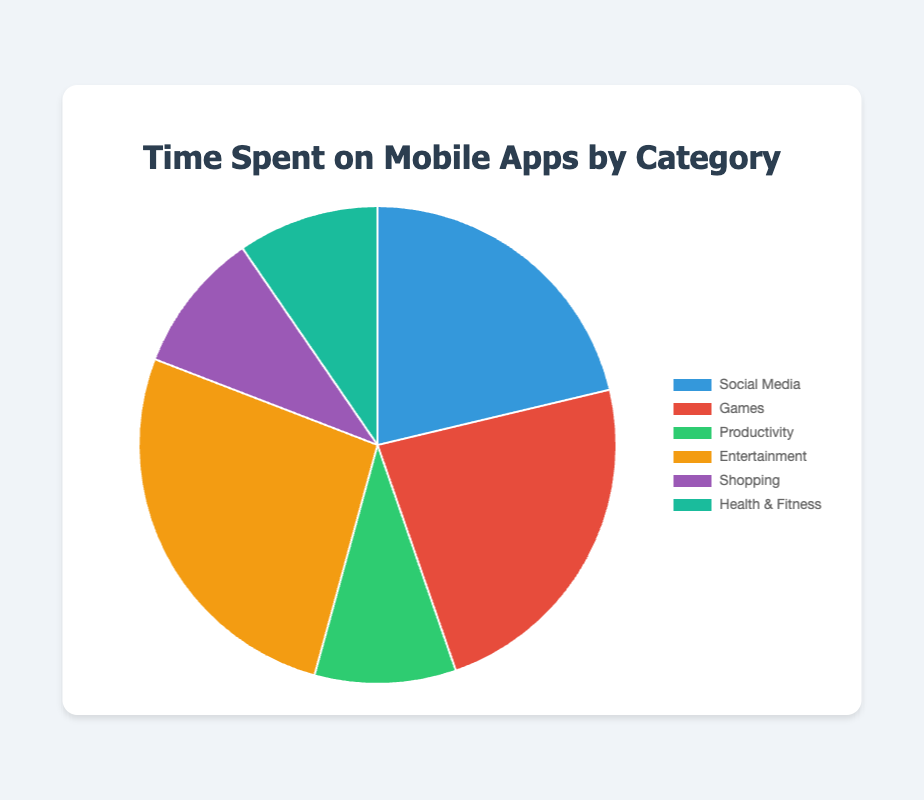Which category has the highest amount of time spent? The chart shows the total time spent on each category. By looking at the pie chart, "Entertainment" has the largest slice, which indicates the highest total time spent.
Answer: Entertainment What is the total time spent on all categories combined? Sum the times spent on each category, visible in the figure: 20 (Social Media) + 22 (Games) + 9 (Productivity) + 25 (Entertainment) + 9 (Shopping) + 9 (Health & Fitness) = 94 hours.
Answer: 94 hours How much more time is spent on Entertainment compared to Productivity? From the pie chart, we see Entertainment is 25 hours and Productivity is 9 hours. The difference is 25 - 9 = 16 hours.
Answer: 16 hours Which two categories have the closest time spent? By examining the pie chart, the categories "Shopping" and "Health & Fitness" both seem to have the same total time spent with 9 hours each.
Answer: Shopping and Health & Fitness What percentage of the total time is spent on Social Media? Social Media takes up 20 hours of the total 94 hours. The percentage is calculated as (20 / 94) * 100 ≈ 21.28%.
Answer: 21.28% What is the average time spent across all categories? The total time spent is 94 hours and there are 6 categories. The average is 94 / 6 ≈ 15.67 hours.
Answer: 15.67 hours Which category has the second-highest amount of time spent? From the pie chart, after Entertainment, Games has the second-highest amount of time spent with 22 hours.
Answer: Games Is the total time spent on Health & Fitness greater than on Shopping? Both categories have the same time spent, so it is neither greater nor less.
Answer: No What is the ratio of time spent on Games to time spent on Productivity? Games have 22 hours and Productivity has 9 hours. The ratio is 22:9.
Answer: 22:9 